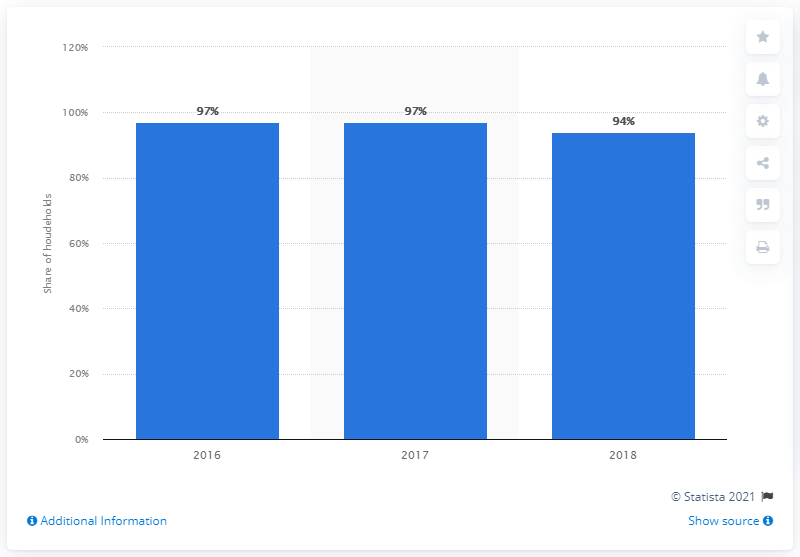Specify some key components in this picture. In 2018, 94% of Finnish households had fixed broadband, which is a type of internet connection that is usually delivered through a physical cable or wire. This means that the majority of Finnish households had access to fast and reliable internet, which has become an essential part of modern life. In 2016 and 2017, the share of Finnish households with fixed broadband was 97%. 